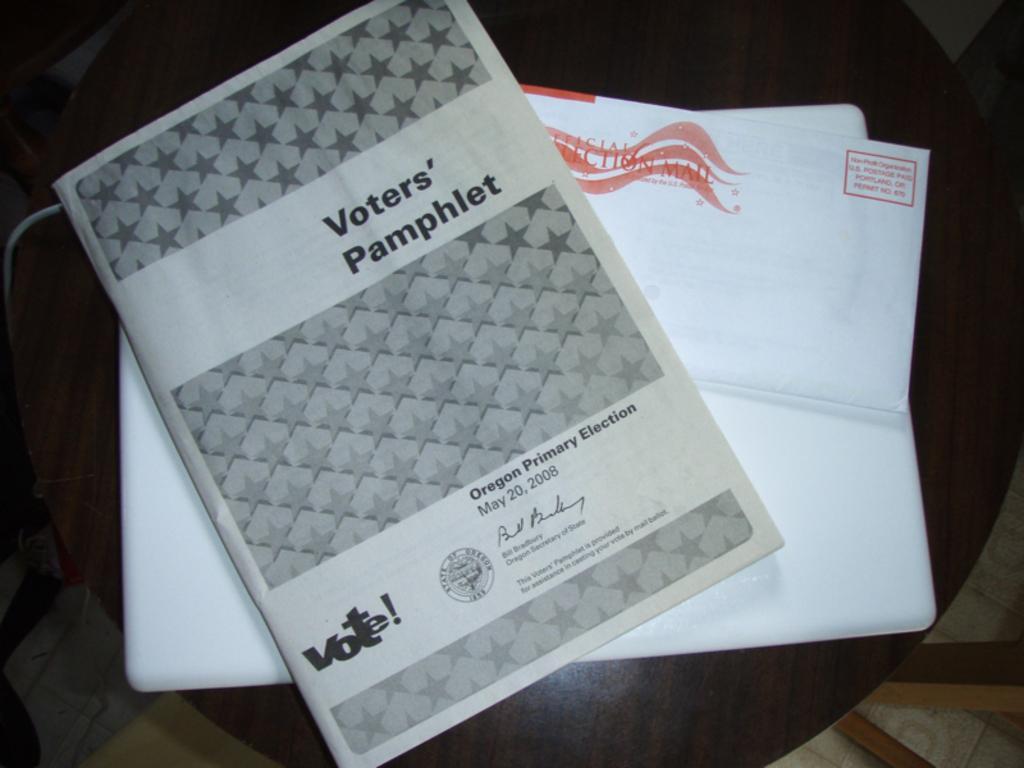Could you give a brief overview of what you see in this image? There is a chair. There is a paper and book on a chair. We can see in background wooden stick and wire. 